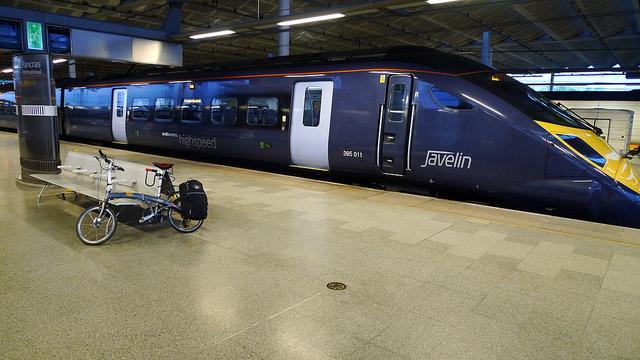Is the train moving?
Be succinct. No. What colors make up the train?
Give a very brief answer. Blue, white and red. What is the bike next to?
Write a very short answer. Bench. 